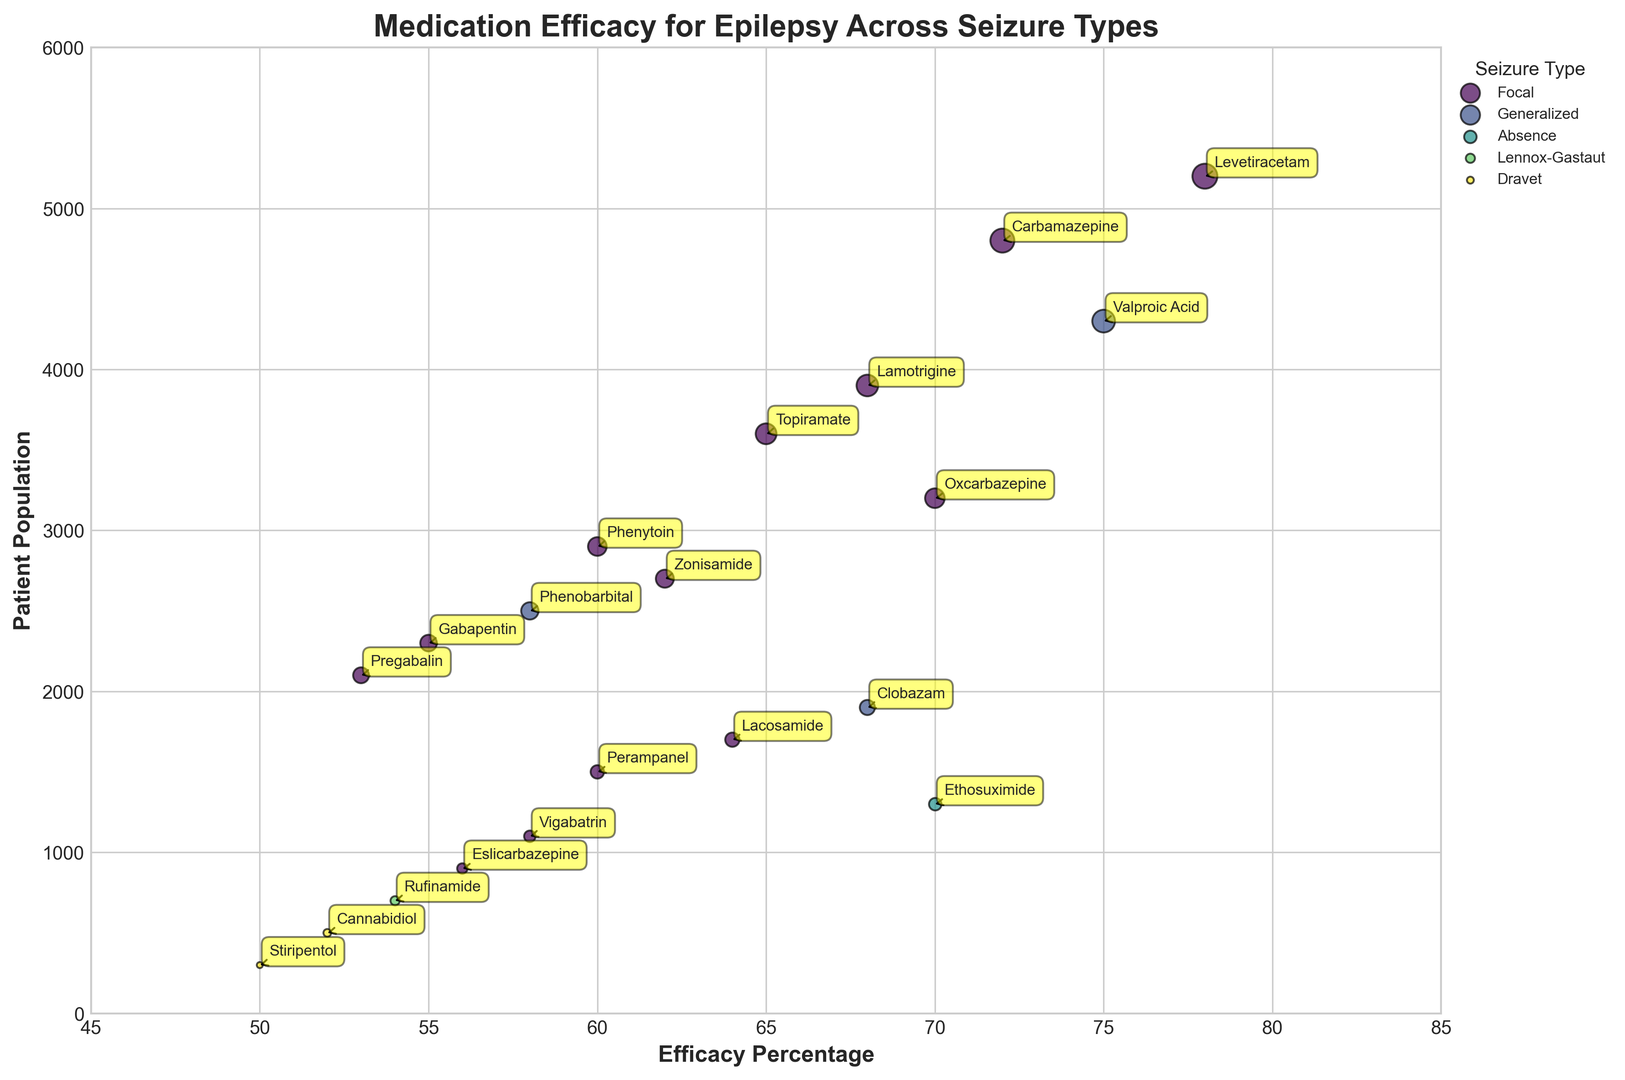What is the medication with the highest efficacy percentage for focal seizures? To find the medication with the highest efficacy percentage for focal seizures, look at the points labeled in the Focal category and locate the one with the highest % value on the x-axis.
Answer: Levetiracetam Compare the patient population for Valproic Acid and Clobazam. Which one has a larger patient population and by how much? First, find the patient population for Valproic Acid and Clobazam by checking the y-axis values for these medications. Valproic Acid has 4300 patients, and Clobazam has 1900 patients. Subtract the smaller from the larger to find the difference: 4300 - 1900 = 2400.
Answer: Valproic Acid by 2400 Identify which seizure type has the most medications listed in the chart. Count the number of different medications associated with each seizure type. Focal has the most medications.
Answer: Focal What is the combined efficacy percentage of Levetiracetam and Carbamazepine? Locate the efficacy percentages for Levetiracetam and Carbamazepine (78% and 72%, respectively). Add them together to get the combined efficacy: 78 + 72 = 150.
Answer: 150 How does the efficacy of Phenobarbital compare to Ethosuximide? Phenobarbital's efficacy is 58%, while Ethosuximide's efficacy is 70%. Ethosuximide is more effective.
Answer: Ethosuximide is more effective For which seizure type is the medication Gabapentin prescribed, and what is its patient population? Find the point labeled Gabapentin, which falls under Focal seizures with a patient population of 2300.
Answer: Focal, 2300 What is the average patient population for medications used to treat Focal seizures? Identify the patient populations for Focal medications, sum them up, and divide by the number of medications. The populations are 5200, 4800, 3900, 3600, 3200, 2900, 2700, 2300, 2100, 1700, 1500, 1100, and 900. The sum is 34900, and there are 13 medications: 34900 / 13 ≈ 2684.62.
Answer: Approximately 2684.62 Which medication is indicated for Dravet syndrome and has the higher efficacy percentage? Identify the medications for Dravet: Cannabidiol and Stiripentol. Compare their efficacy percentages, 52% and 50%, respectively. Cannabidiol has higher efficacy.
Answer: Cannabidiol What is the efficacy difference between Topiramate and Lacosamide? Locate Topiramate (65%) and Lacosamide (64%) on the x-axis. Subtract Lacosamide's efficacy from Topiramate's: 65 - 64 = 1.
Answer: 1 Which medication among those listed is for Lennox-Gastaut syndrome, and what is its efficacy percentage? Find the medication labeled for Lennox-Gastaut, which is Rufinamide with an efficacy percentage of 54%.
Answer: Rufinamide, 54 